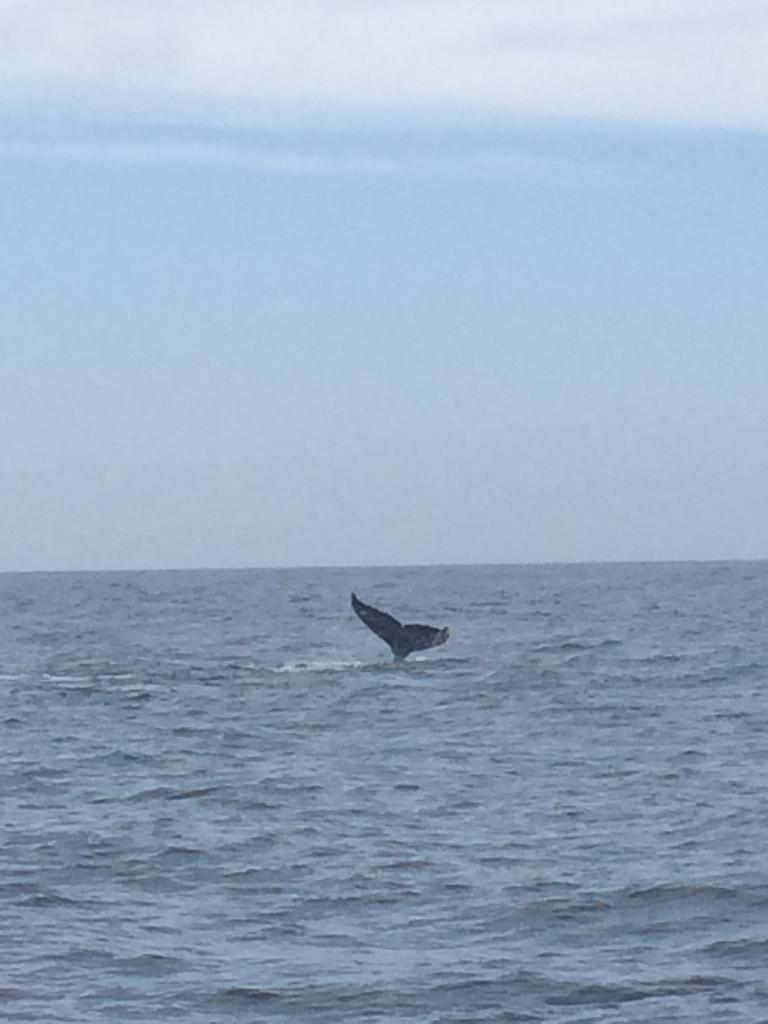In one or two sentences, can you explain what this image depicts? In this image there is a tail of a shark in the water. In the background of the image there is sky. 